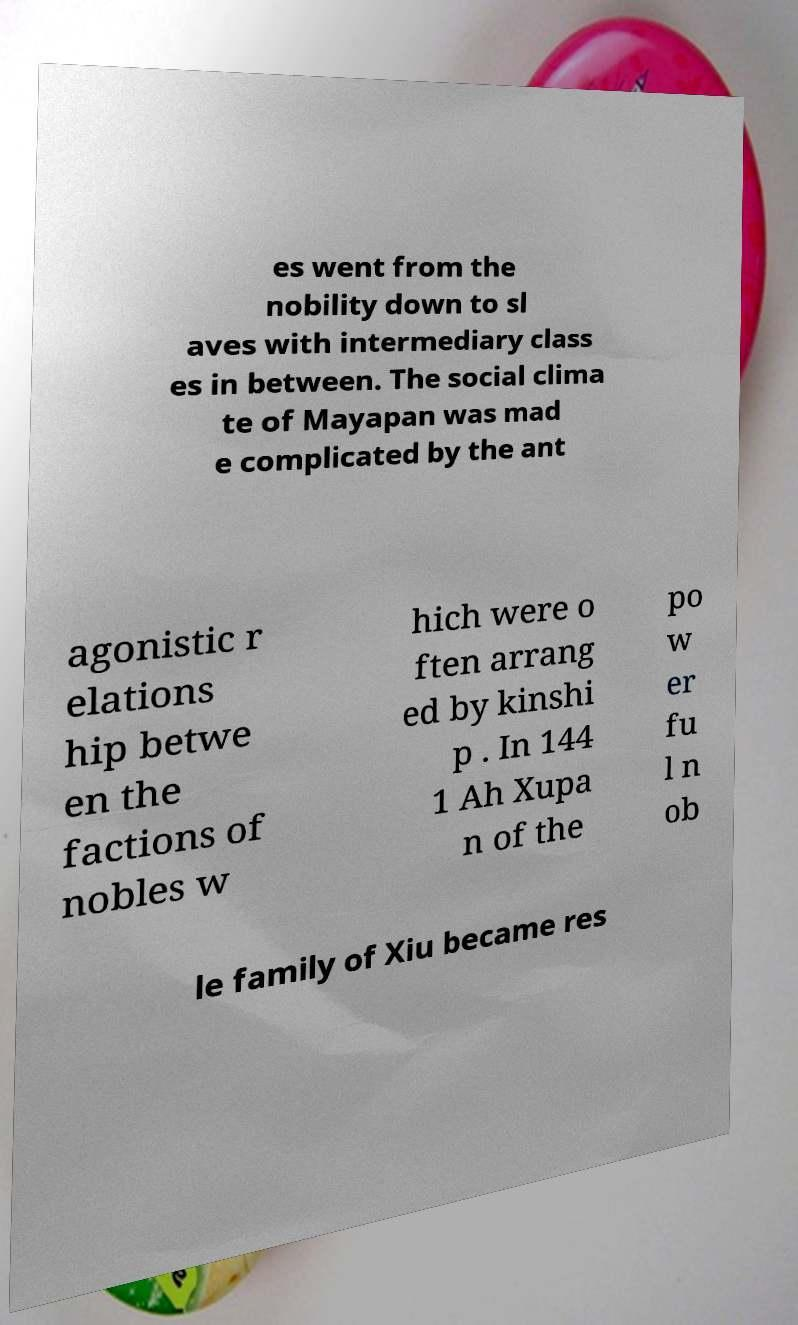What messages or text are displayed in this image? I need them in a readable, typed format. es went from the nobility down to sl aves with intermediary class es in between. The social clima te of Mayapan was mad e complicated by the ant agonistic r elations hip betwe en the factions of nobles w hich were o ften arrang ed by kinshi p . In 144 1 Ah Xupa n of the po w er fu l n ob le family of Xiu became res 